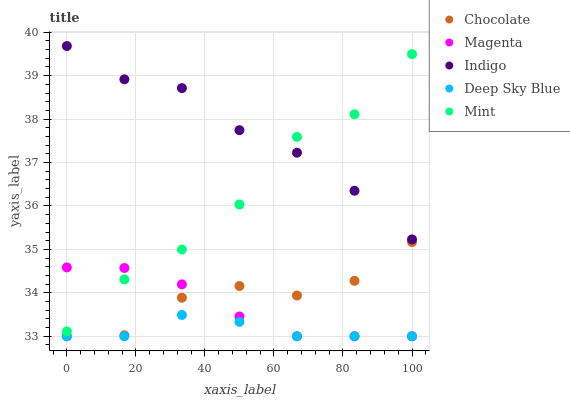Does Deep Sky Blue have the minimum area under the curve?
Answer yes or no. Yes. Does Indigo have the maximum area under the curve?
Answer yes or no. Yes. Does Magenta have the minimum area under the curve?
Answer yes or no. No. Does Magenta have the maximum area under the curve?
Answer yes or no. No. Is Magenta the smoothest?
Answer yes or no. Yes. Is Mint the roughest?
Answer yes or no. Yes. Is Indigo the smoothest?
Answer yes or no. No. Is Indigo the roughest?
Answer yes or no. No. Does Magenta have the lowest value?
Answer yes or no. Yes. Does Indigo have the lowest value?
Answer yes or no. No. Does Indigo have the highest value?
Answer yes or no. Yes. Does Magenta have the highest value?
Answer yes or no. No. Is Magenta less than Indigo?
Answer yes or no. Yes. Is Mint greater than Deep Sky Blue?
Answer yes or no. Yes. Does Magenta intersect Chocolate?
Answer yes or no. Yes. Is Magenta less than Chocolate?
Answer yes or no. No. Is Magenta greater than Chocolate?
Answer yes or no. No. Does Magenta intersect Indigo?
Answer yes or no. No. 